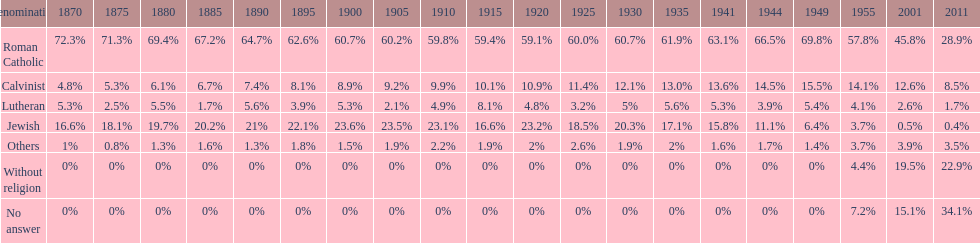Which denomination held the largest percentage in 1880? Roman Catholic. 